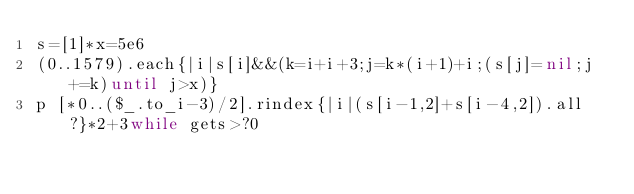<code> <loc_0><loc_0><loc_500><loc_500><_Ruby_>s=[1]*x=5e6
(0..1579).each{|i|s[i]&&(k=i+i+3;j=k*(i+1)+i;(s[j]=nil;j+=k)until j>x)}
p [*0..($_.to_i-3)/2].rindex{|i|(s[i-1,2]+s[i-4,2]).all?}*2+3while gets>?0</code> 